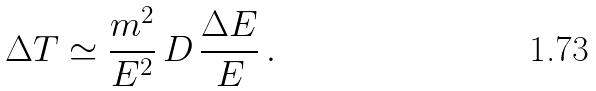Convert formula to latex. <formula><loc_0><loc_0><loc_500><loc_500>\Delta { T } \simeq \frac { m ^ { 2 } } { E ^ { 2 } } \, D \, \frac { \Delta { E } } { E } \, .</formula> 